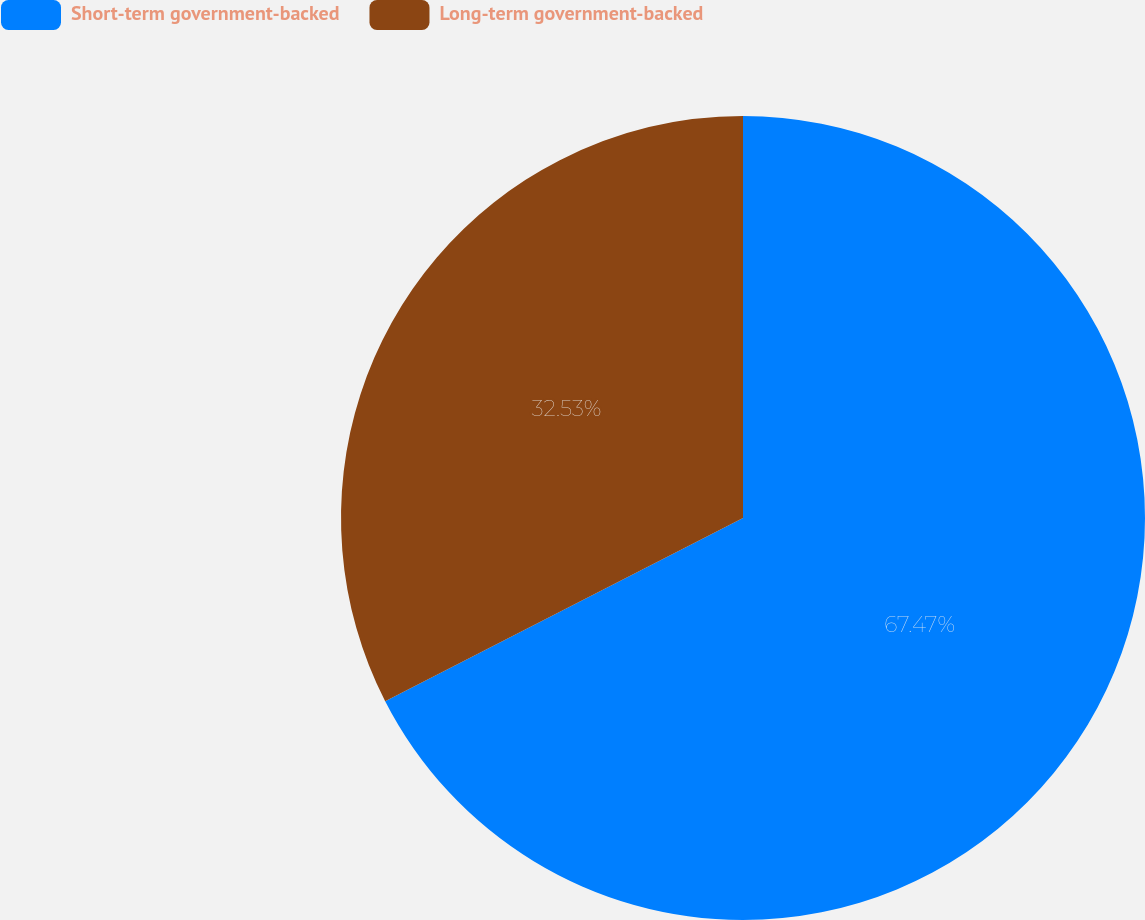<chart> <loc_0><loc_0><loc_500><loc_500><pie_chart><fcel>Short-term government-backed<fcel>Long-term government-backed<nl><fcel>67.47%<fcel>32.53%<nl></chart> 